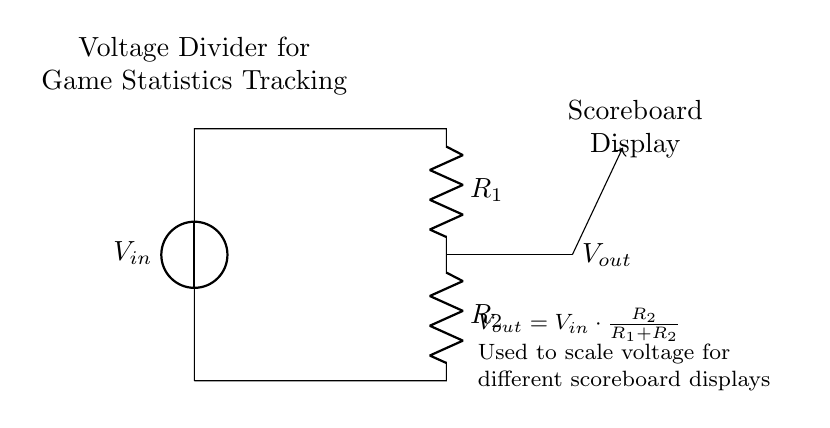What are the two resistors in the circuit? The resistors in the circuit are labeled as R1 and R2, where R1 is connected between the input voltage and the output voltage point, and R2 is connected from that point to ground.
Answer: R1 and R2 What is the formula for Vout? The output voltage Vout is calculated using the formula Vout equals Vin times the fraction of R2 divided by the total resistance, which is R1 plus R2.
Answer: Vout = Vin * (R2 / (R1 + R2)) What is the purpose of the voltage divider in the circuit? The voltage divider is used to scale the input voltage to a usable level for the scoreboard display, allowing for the adjustment of voltage based on different technical requirements of the display system.
Answer: Scale voltage What happens to Vout if R2 is increased? If R2 is increased while R1 remains constant, the fraction R2 divided by (R1 + R2) becomes larger, resulting in a higher output voltage Vout.
Answer: Vout increases What type of circuit is this? This is specifically a voltage divider circuit, which is utilized to produce a lower output voltage from a higher input voltage.
Answer: Voltage divider How does this circuit relate to game statistics? The circuit effectively helps in displaying game statistics by converting the raw voltage signals into appropriate values that can be displayed on the scoreboard, ensuring that the data is understandable for viewers.
Answer: Game statistics tracking 